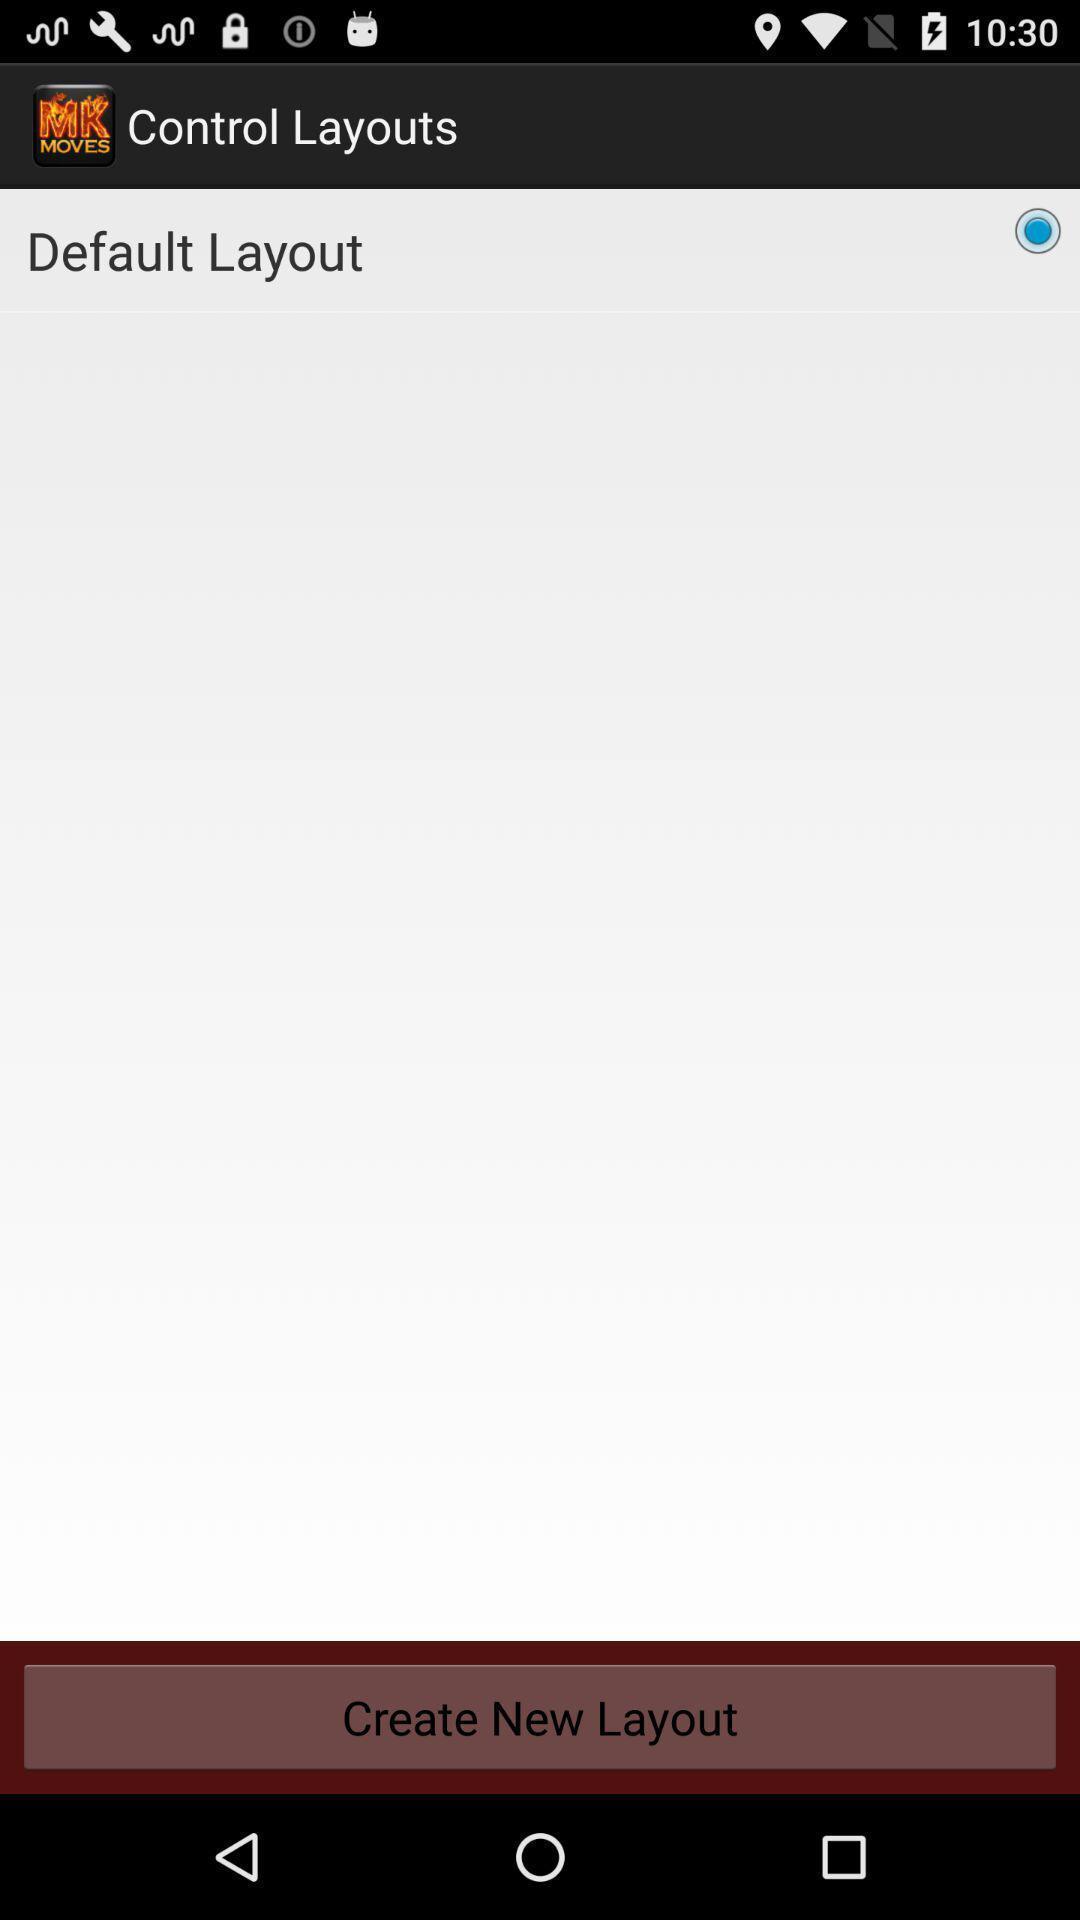Provide a detailed account of this screenshot. Window displaying a layout page. 